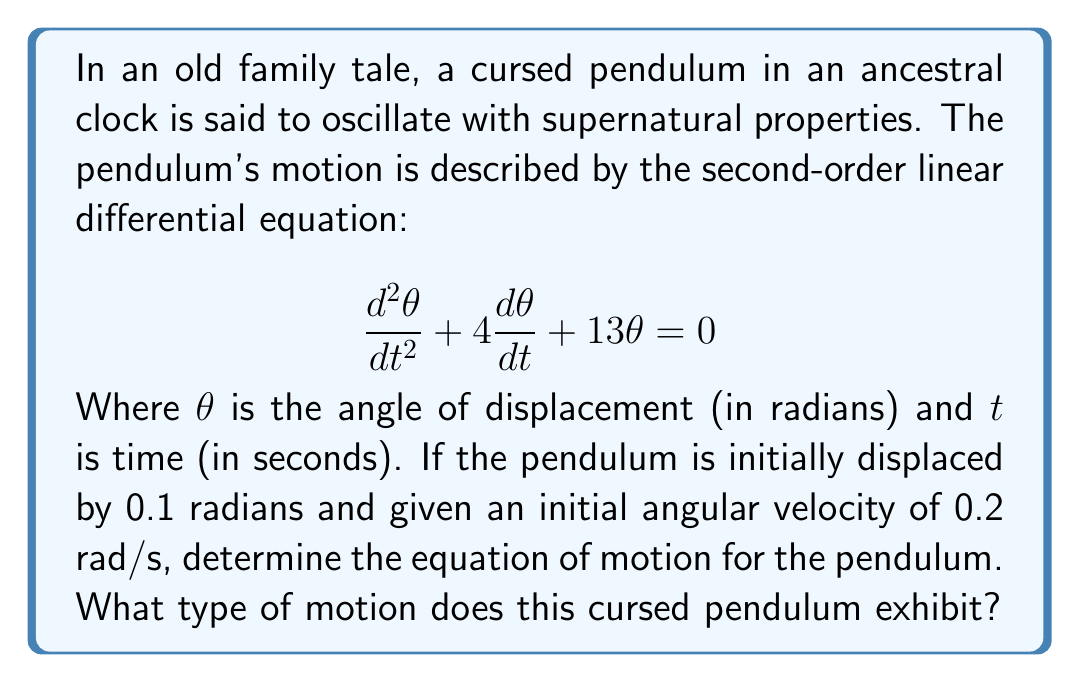Can you answer this question? To solve this problem, we'll follow these steps:

1) First, we need to identify the characteristic equation of the given differential equation:

   $$r^2 + 4r + 13 = 0$$

2) Solve the characteristic equation:
   $$r = \frac{-4 \pm \sqrt{4^2 - 4(1)(13)}}{2(1)} = \frac{-4 \pm \sqrt{16 - 52}}{2} = \frac{-4 \pm \sqrt{-36}}{2} = -2 \pm 3i$$

3) Since the roots are complex conjugates, the general solution has the form:

   $$\theta(t) = e^{-2t}(A\cos(3t) + B\sin(3t))$$

   Where $A$ and $B$ are constants determined by initial conditions.

4) Given initial conditions:
   $\theta(0) = 0.1$ and $\frac{d\theta}{dt}(0) = 0.2$

5) Apply the initial conditions:
   $\theta(0) = A = 0.1$

   $\frac{d\theta}{dt}(0) = -2A + 3B = 0.2$

6) Solve for $B$:
   $-2(0.1) + 3B = 0.2$
   $3B = 0.4$
   $B = \frac{0.4}{3} \approx 0.133$

7) Therefore, the equation of motion is:

   $$\theta(t) = e^{-2t}(0.1\cos(3t) + 0.133\sin(3t))$$

This equation represents underdamped motion. The exponential term $e^{-2t}$ causes the amplitude to decrease over time, while the sine and cosine terms cause oscillation. This results in a decaying oscillatory motion.
Answer: The equation of motion for the cursed pendulum is:
$$\theta(t) = e^{-2t}(0.1\cos(3t) + 0.133\sin(3t))$$
The pendulum exhibits underdamped motion, characterized by decaying oscillations. 